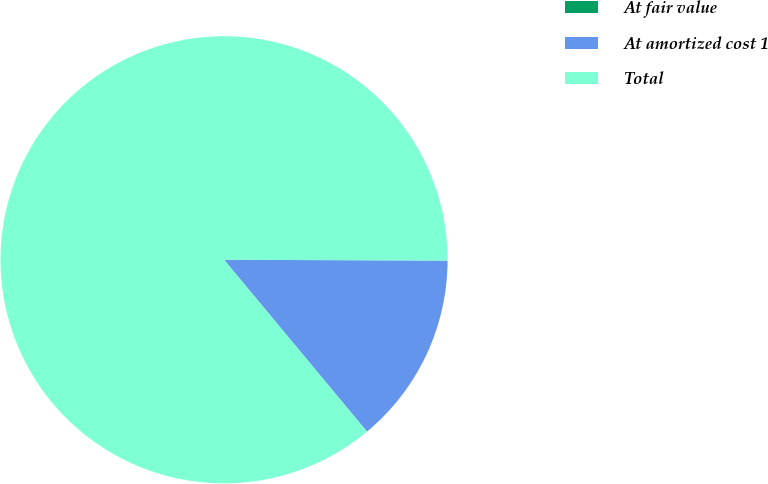Convert chart to OTSL. <chart><loc_0><loc_0><loc_500><loc_500><pie_chart><fcel>At fair value<fcel>At amortized cost 1<fcel>Total<nl><fcel>0.01%<fcel>13.9%<fcel>86.09%<nl></chart> 